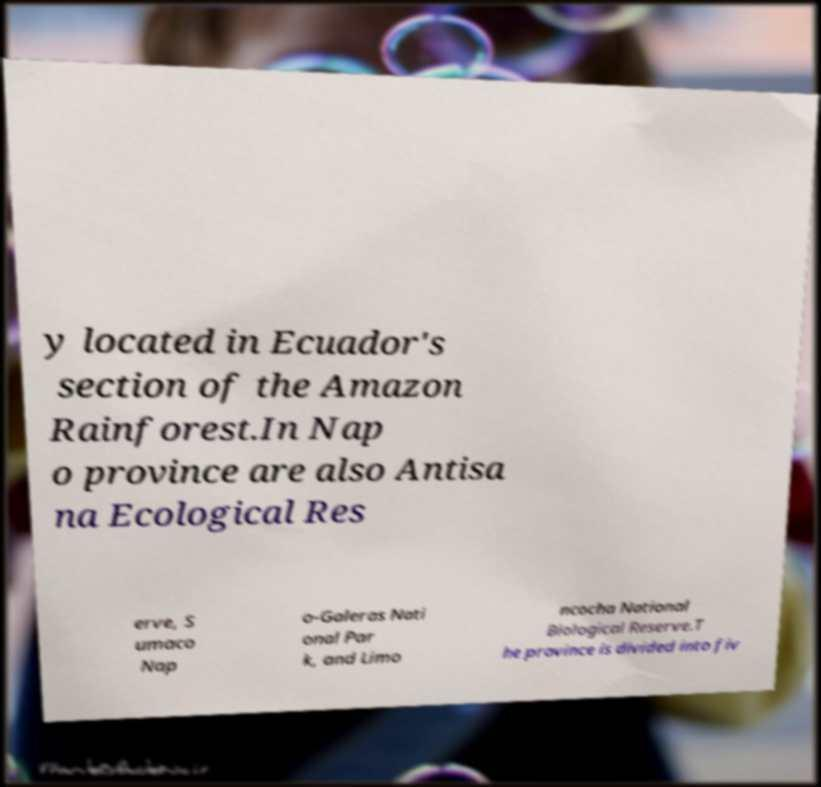Could you extract and type out the text from this image? y located in Ecuador's section of the Amazon Rainforest.In Nap o province are also Antisa na Ecological Res erve, S umaco Nap o-Galeras Nati onal Par k, and Limo ncocha National Biological Reserve.T he province is divided into fiv 